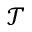Convert formula to latex. <formula><loc_0><loc_0><loc_500><loc_500>\mathcal { T }</formula> 